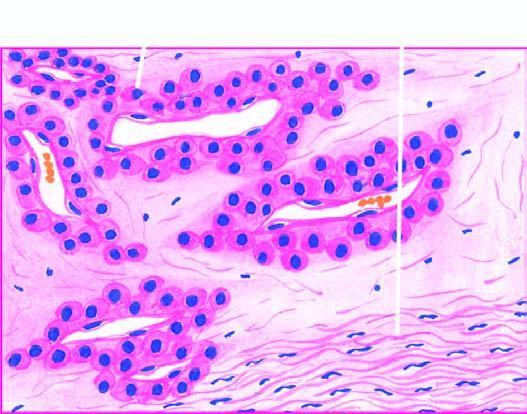what are there?
Answer the question using a single word or phrase. Blood-filled vascular channels 